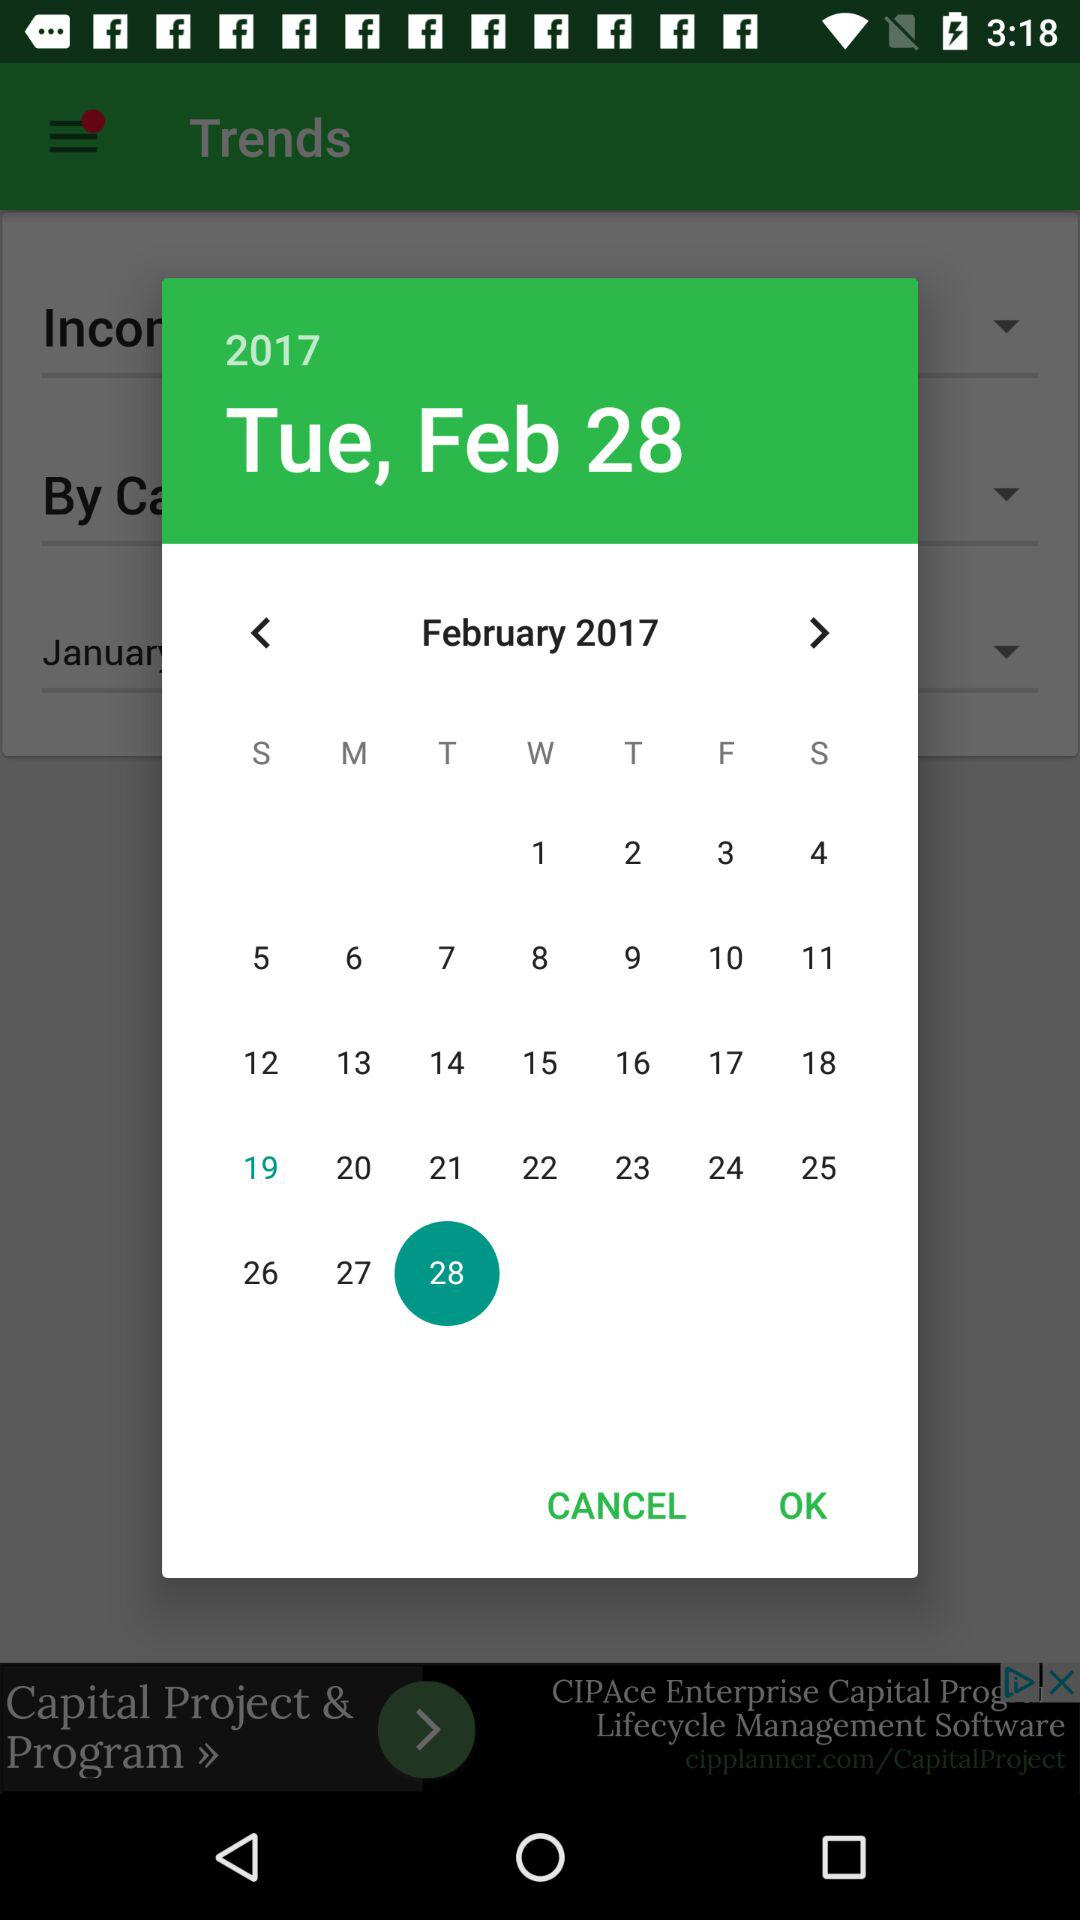What day is it on the selected date? The day is Tuesday. 